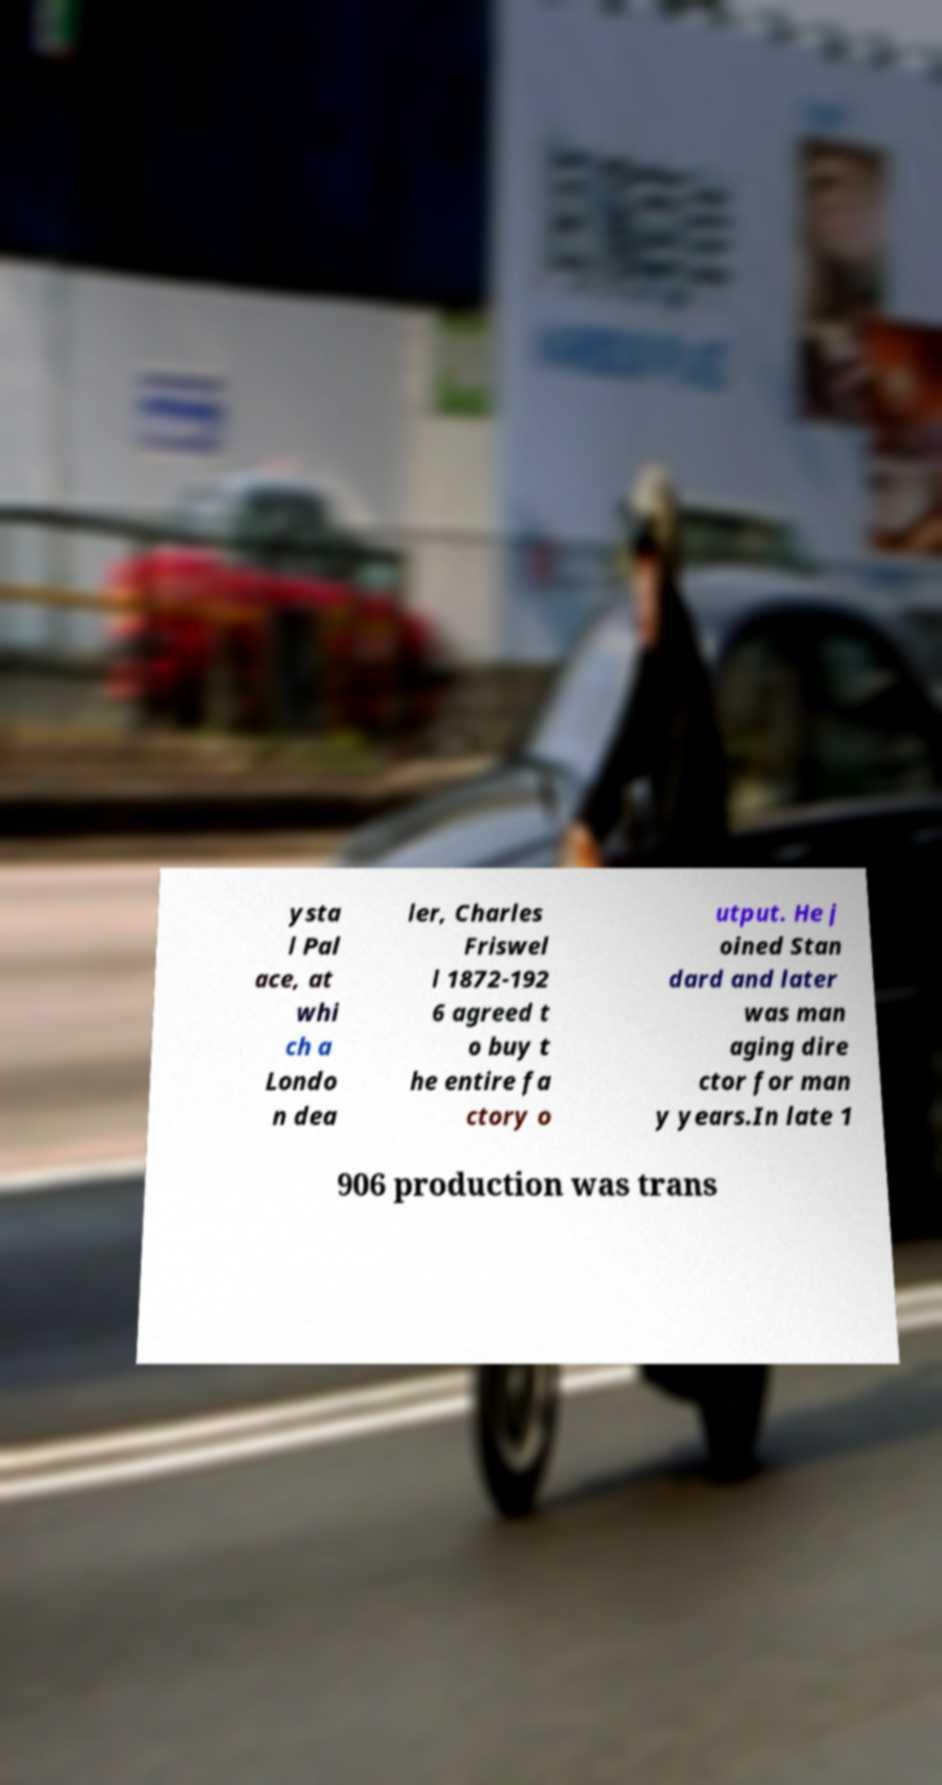Please identify and transcribe the text found in this image. ysta l Pal ace, at whi ch a Londo n dea ler, Charles Friswel l 1872-192 6 agreed t o buy t he entire fa ctory o utput. He j oined Stan dard and later was man aging dire ctor for man y years.In late 1 906 production was trans 